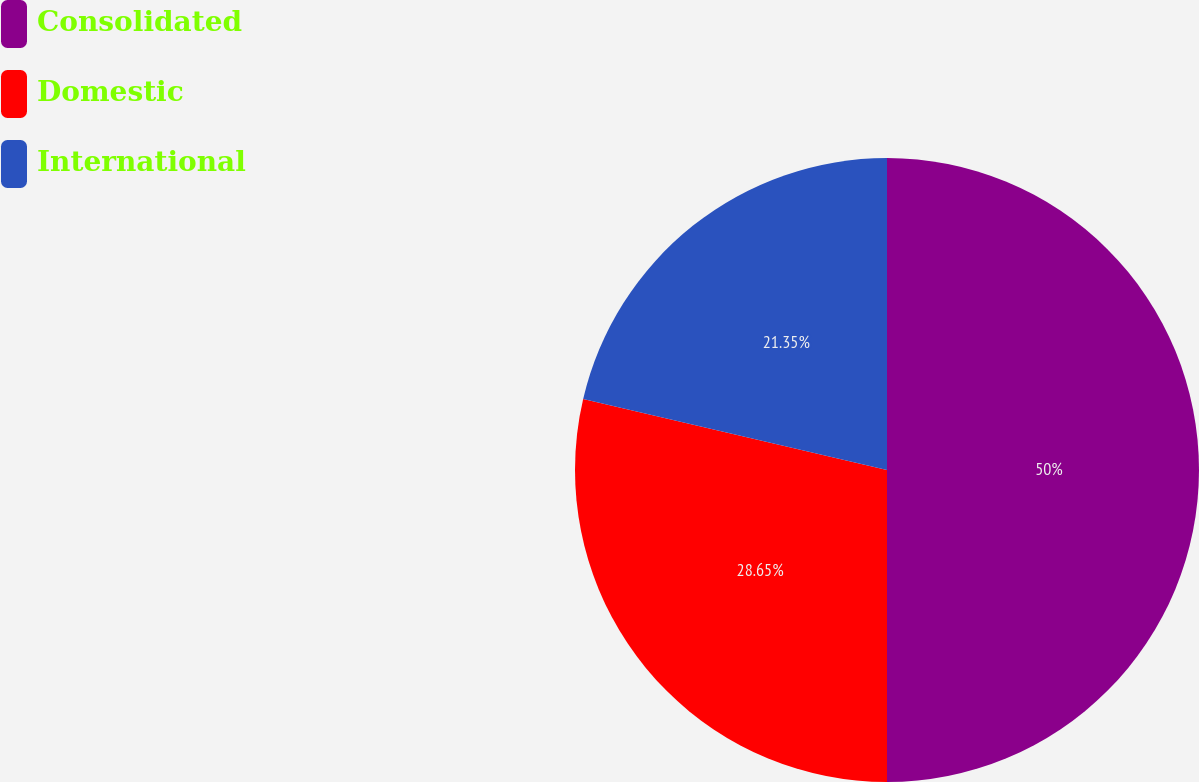<chart> <loc_0><loc_0><loc_500><loc_500><pie_chart><fcel>Consolidated<fcel>Domestic<fcel>International<nl><fcel>50.0%<fcel>28.65%<fcel>21.35%<nl></chart> 